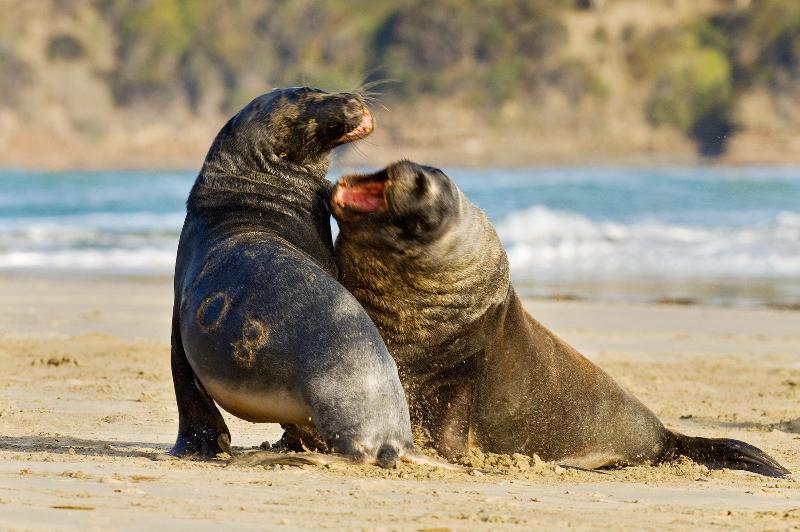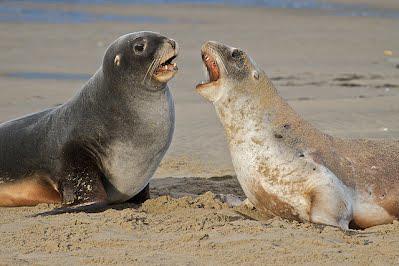The first image is the image on the left, the second image is the image on the right. Evaluate the accuracy of this statement regarding the images: "Right and left image contain the same number of seals.". Is it true? Answer yes or no. Yes. The first image is the image on the left, the second image is the image on the right. Examine the images to the left and right. Is the description "The photo on the right contains three or more animals." accurate? Answer yes or no. No. 